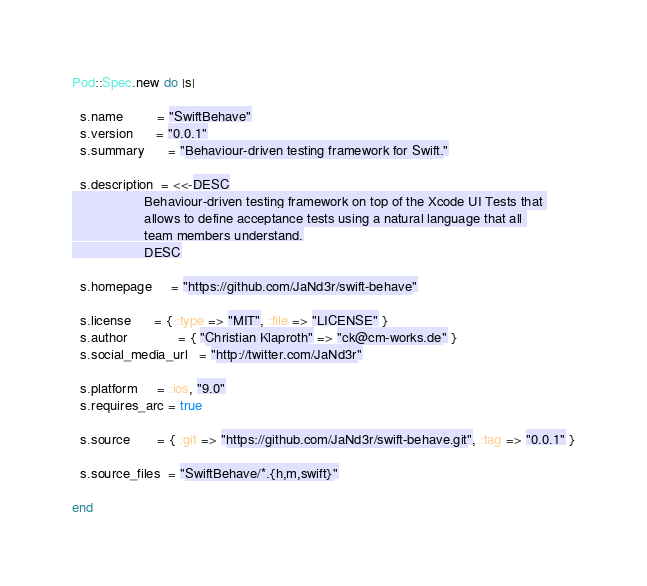<code> <loc_0><loc_0><loc_500><loc_500><_Ruby_>
Pod::Spec.new do |s|

  s.name         = "SwiftBehave"
  s.version      = "0.0.1"
  s.summary      = "Behaviour-driven testing framework for Swift."

  s.description  = <<-DESC
                   Behaviour-driven testing framework on top of the Xcode UI Tests that 
                   allows to define acceptance tests using a natural language that all 
                   team members understand.
                   DESC

  s.homepage     = "https://github.com/JaNd3r/swift-behave"
  
  s.license      = { :type => "MIT", :file => "LICENSE" }
  s.author             = { "Christian Klaproth" => "ck@cm-works.de" }
  s.social_media_url   = "http://twitter.com/JaNd3r"

  s.platform     = :ios, "9.0"
  s.requires_arc = true

  s.source       = { :git => "https://github.com/JaNd3r/swift-behave.git", :tag => "0.0.1" }

  s.source_files  = "SwiftBehave/*.{h,m,swift}"

end
</code> 